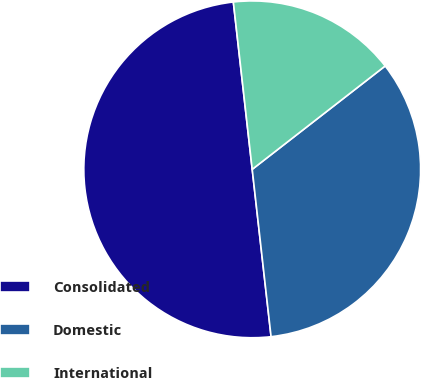Convert chart. <chart><loc_0><loc_0><loc_500><loc_500><pie_chart><fcel>Consolidated<fcel>Domestic<fcel>International<nl><fcel>50.0%<fcel>33.73%<fcel>16.27%<nl></chart> 